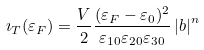<formula> <loc_0><loc_0><loc_500><loc_500>\imath _ { T } ( \varepsilon _ { F } ) = \frac { V } { 2 } \frac { ( \varepsilon _ { F } - \varepsilon _ { 0 } ) ^ { 2 } } { \varepsilon _ { 1 0 } \varepsilon _ { 2 0 } \varepsilon _ { 3 0 } } \left | { b } \right | ^ { n }</formula> 